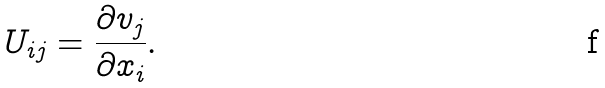Convert formula to latex. <formula><loc_0><loc_0><loc_500><loc_500>U _ { i j } = \frac { \partial v _ { j } } { \partial x _ { i } } .</formula> 